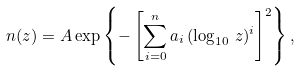Convert formula to latex. <formula><loc_0><loc_0><loc_500><loc_500>n ( z ) = A \exp \left \{ - \left [ \sum _ { i = 0 } ^ { n } a _ { i } \, ( \log _ { 1 0 } \, z ) ^ { i } \right ] ^ { 2 } \right \} ,</formula> 